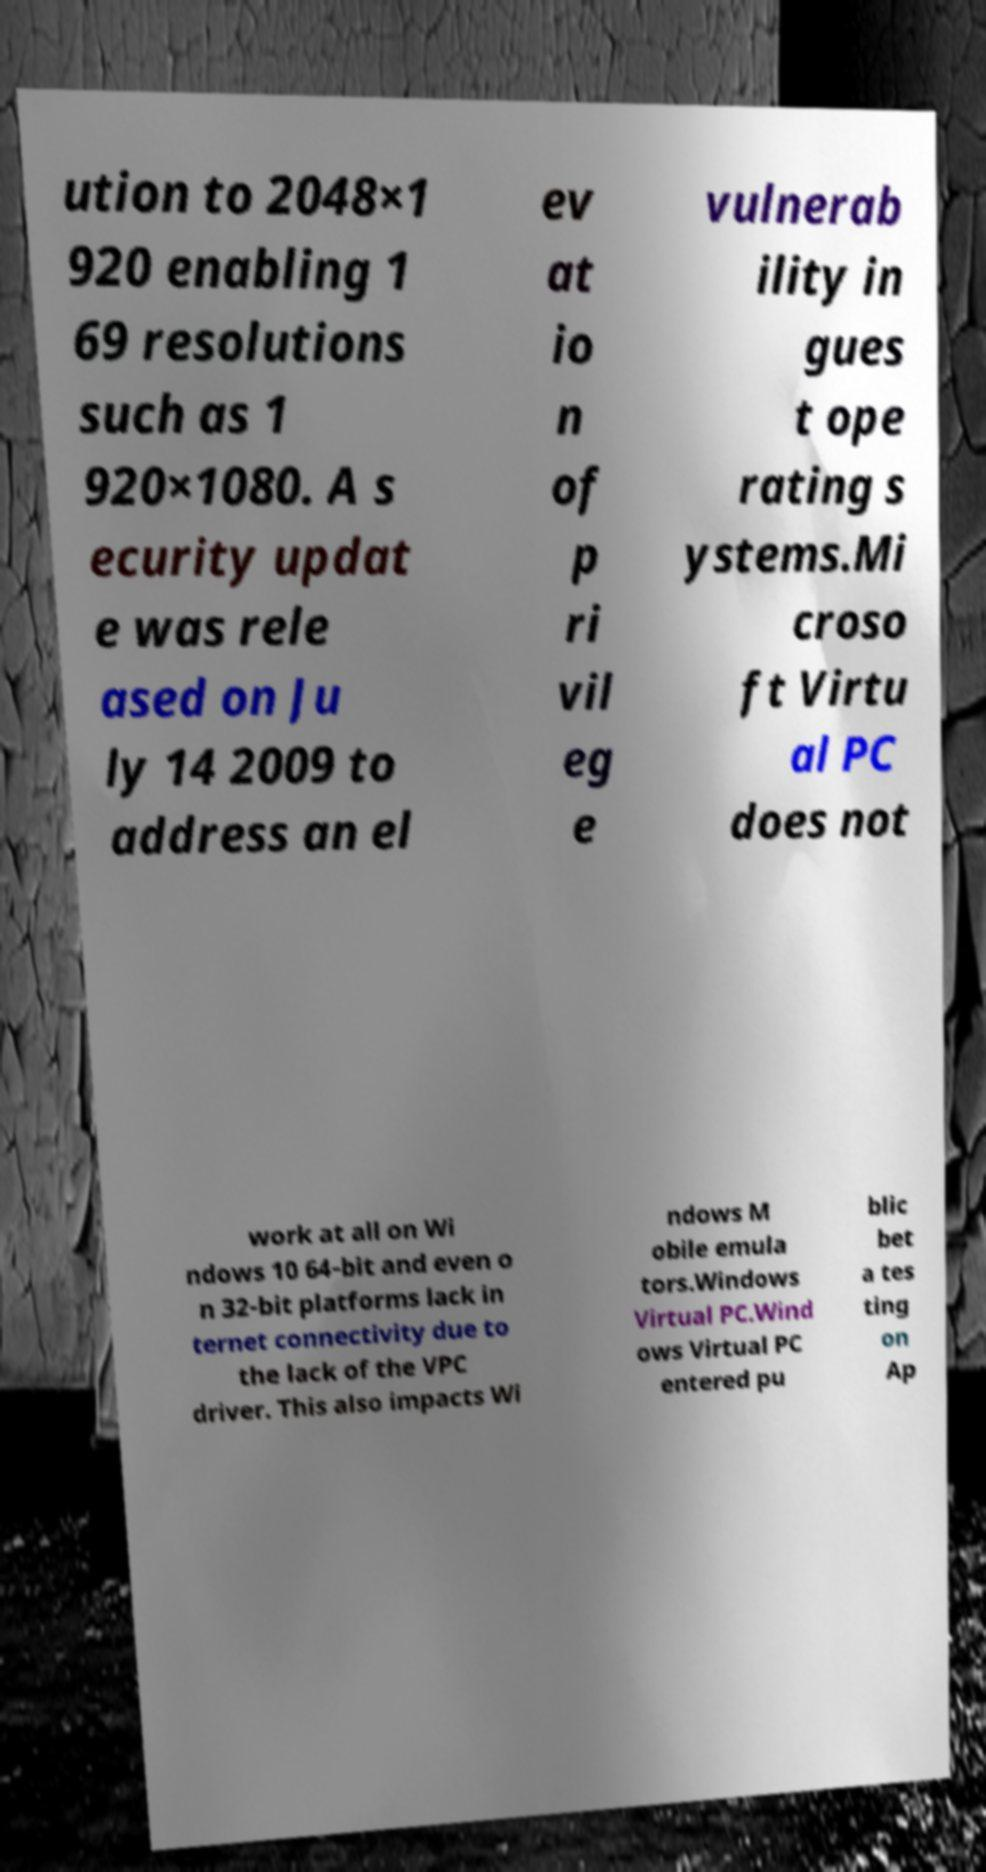Could you assist in decoding the text presented in this image and type it out clearly? ution to 2048×1 920 enabling 1 69 resolutions such as 1 920×1080. A s ecurity updat e was rele ased on Ju ly 14 2009 to address an el ev at io n of p ri vil eg e vulnerab ility in gues t ope rating s ystems.Mi croso ft Virtu al PC does not work at all on Wi ndows 10 64-bit and even o n 32-bit platforms lack in ternet connectivity due to the lack of the VPC driver. This also impacts Wi ndows M obile emula tors.Windows Virtual PC.Wind ows Virtual PC entered pu blic bet a tes ting on Ap 